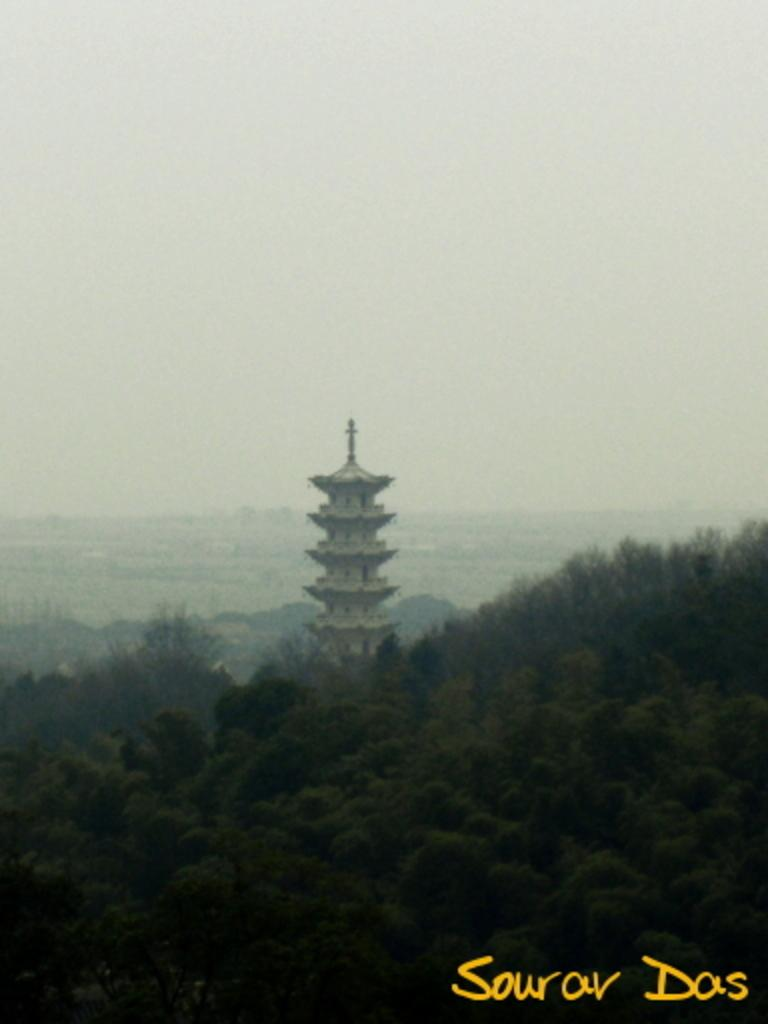What type of structure is present in the image? There is a building in the image. What else can be seen in the image besides the building? There are many trees in the image. What is visible at the top of the image? The sky is clear and visible at the top of the image. Can you see the band performing in the image? There is no band present in the image; it features a building and trees. How many knees are visible in the image? There are no knees visible in the image, as it does not depict any people or animals. 